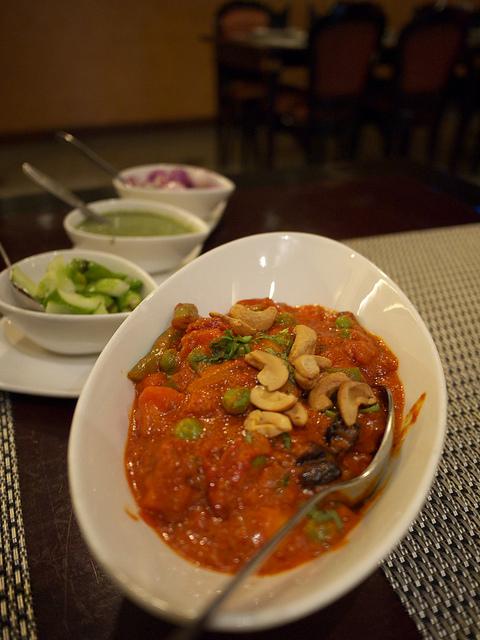How many bowls are in the picture?
Short answer required. 4. Is this a main course or dessert food?
Short answer required. Main course. Does this soup resemble salsa?
Answer briefly. Yes. What utensils can be seen?
Concise answer only. Spoons. How many utensils are in this picture?
Be succinct. 4. What utensils are on the plates?
Be succinct. Spoons. 